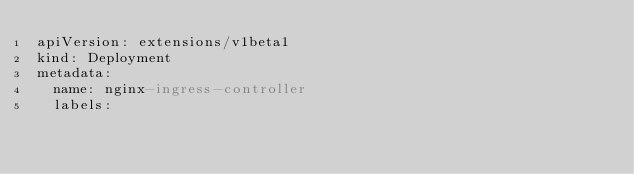Convert code to text. <code><loc_0><loc_0><loc_500><loc_500><_YAML_>apiVersion: extensions/v1beta1
kind: Deployment
metadata:
  name: nginx-ingress-controller
  labels:</code> 